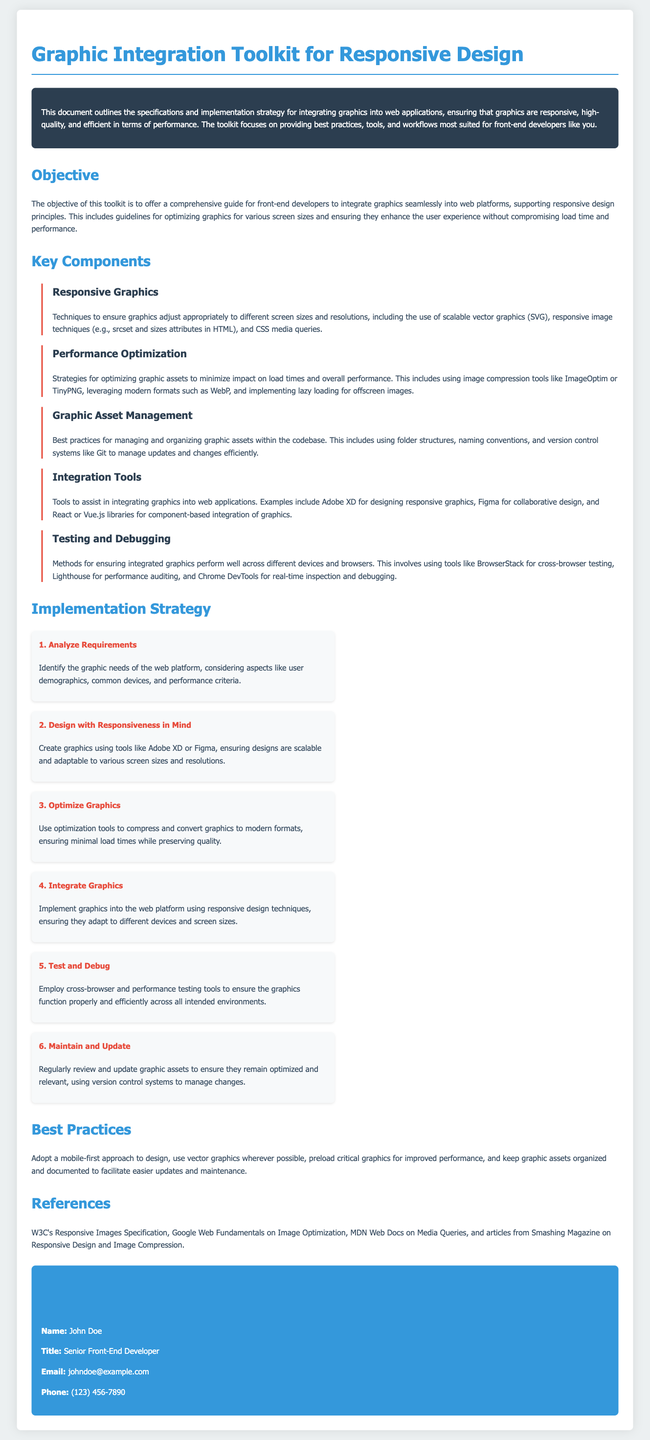What is the title of the document? The title of the document is displayed prominently at the top of the rendered document.
Answer: Graphic Integration Toolkit for Responsive Design Who is the author of the document? The author's information is provided in the contact information section.
Answer: John Doe What color is used for the primary text? The primary text color is specified in the CSS root variables and is shown directly in the document's styling.
Answer: #34495e What is the first step in the implementation strategy? The steps of the implementation strategy are enumerated in the document, with the first step highlighted.
Answer: Analyze Requirements What optimization tools are mentioned for graphic assets? The document lists specific tools used for optimization under the performance optimization section.
Answer: ImageOptim, TinyPNG What approach to design does the document recommend? The recommended design approach is stated clearly in the best practices section of the document.
Answer: Mobile-first approach What is the objective of the toolkit? The objective is outlined in a dedicated section of the document that describes the purpose of the toolkit.
Answer: Integrate graphics seamlessly into web platforms Which tools are suggested for graphic design? Tools for designing graphics are specifically noted in one of the subsections regarding integration tools.
Answer: Adobe XD, Figma How many steps are there in the implementation strategy? The document includes a list of steps, allowing for a straightforward count.
Answer: 6 steps 